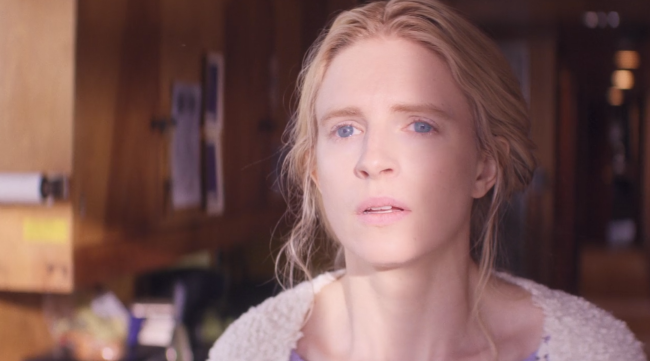What is this photo about? In this image, the focus is on a woman with blonde hair styled in loose waves, wearing a white sweater. She is standing in a room with wooden walls and a window in the background, which lets in soft natural light. Her serious expression suggests she is deep in thought, possibly contemplating something significant. The overall atmosphere of the image is serene and introspective, with a gentle warmth provided by the light and her cozy attire. 